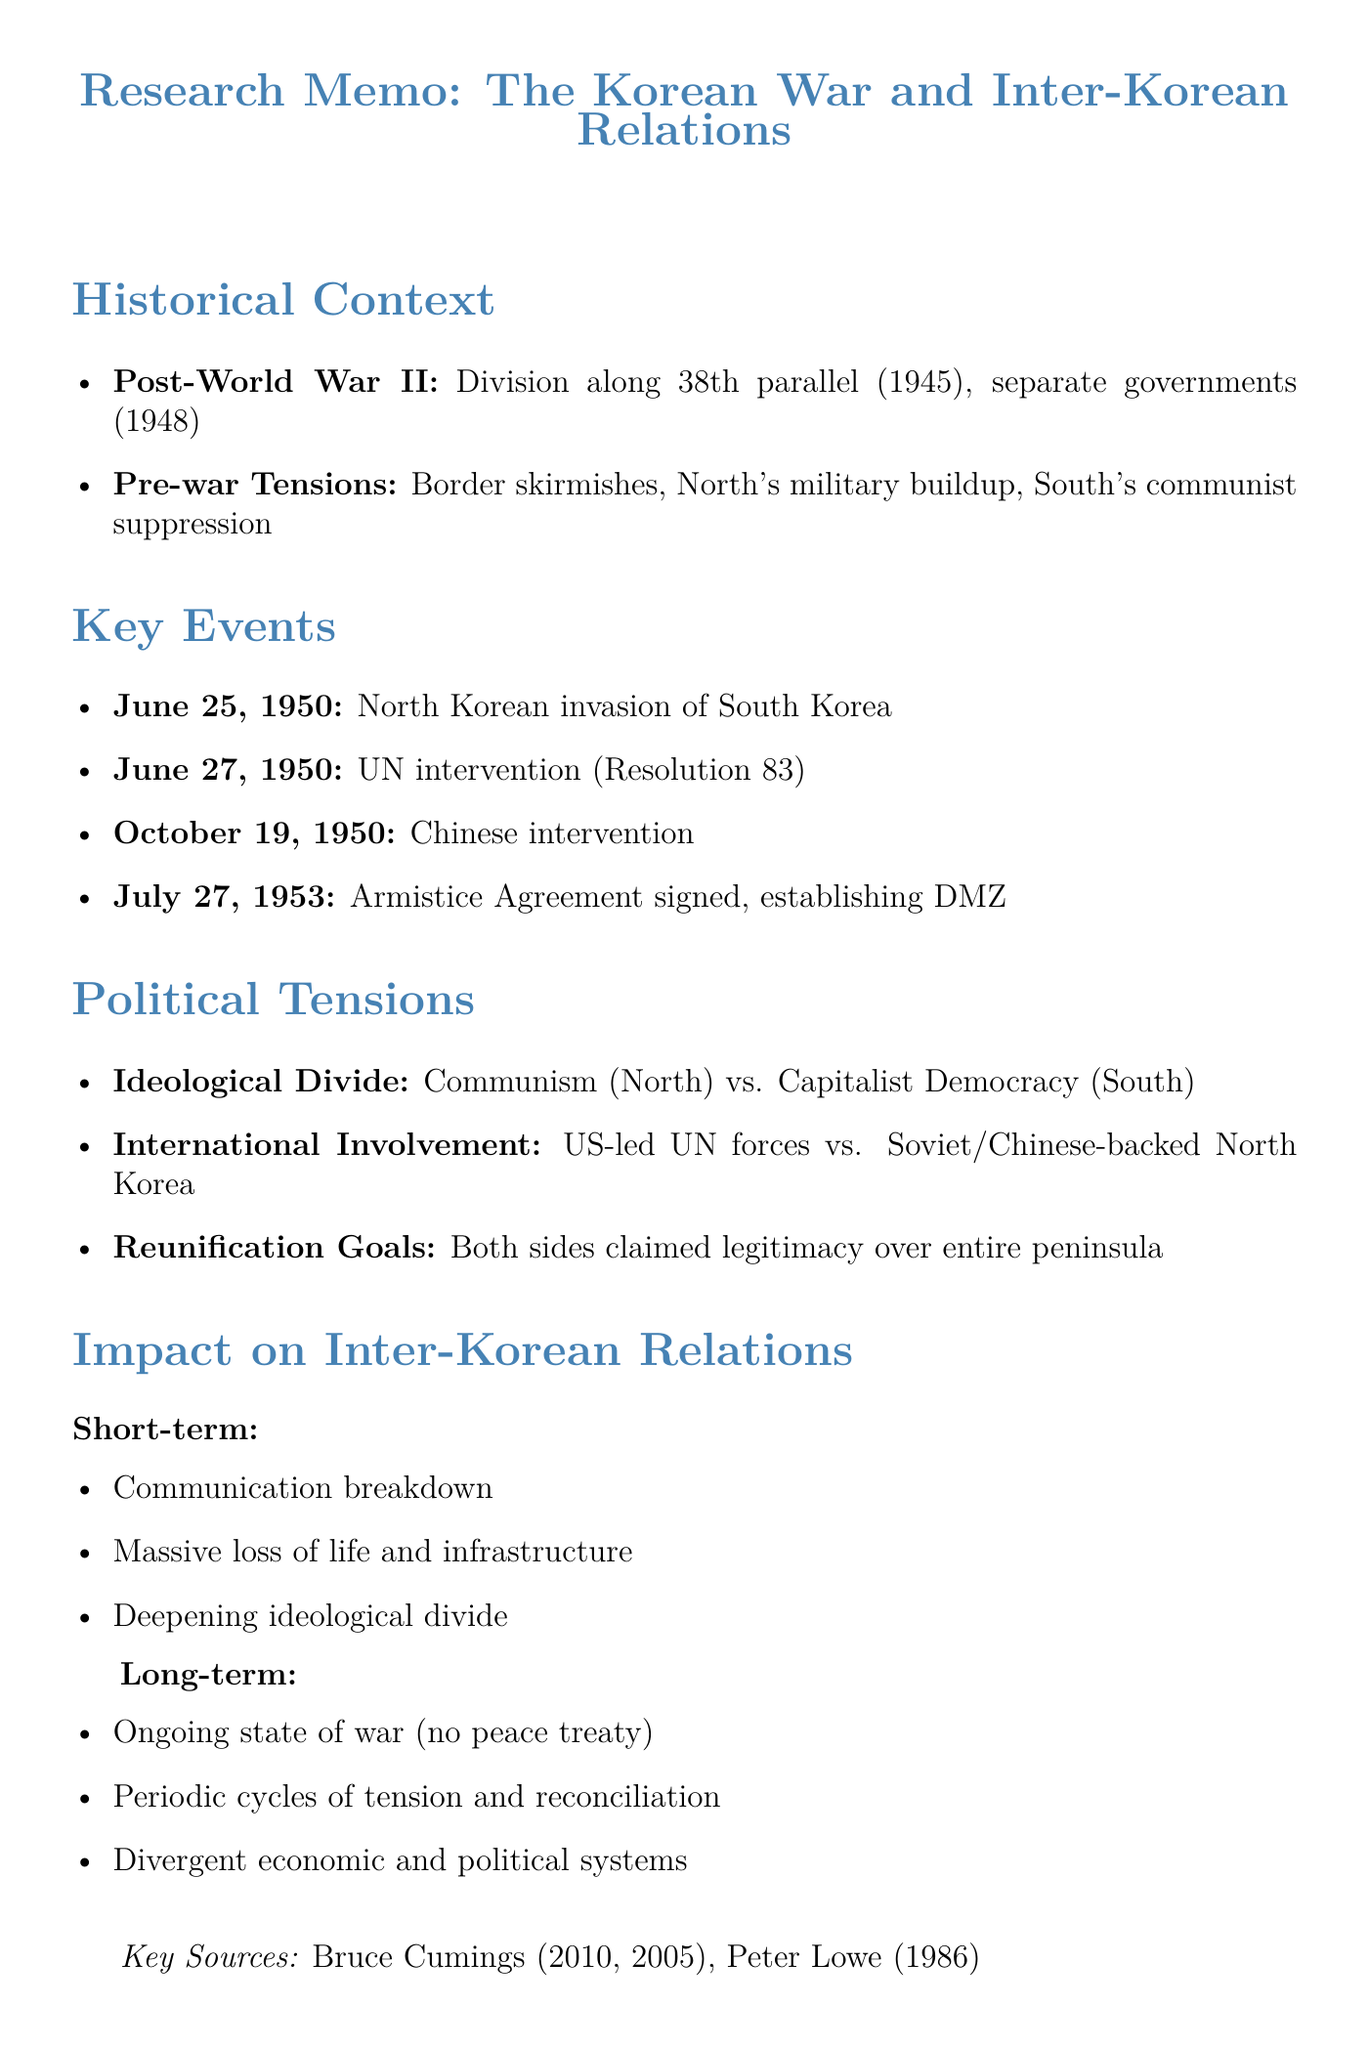what event initiated the Korean War? The document states that North Korean forces crossed the 38th parallel, marking the beginning of the war.
Answer: North Korean invasion of South Korea when was the Armistice Agreement signed? The document lists the date when the Armistice Agreement was signed.
Answer: July 27, 1953 who were the key figures representing the ideological divide? The document identifies key figures for both the North and South in relation to their ideological beliefs.
Answer: Kim Il-sung, Syngman Rhee what was a significant outcome of the Korean War on inter-Korean relations in the short term? The document mentions several immediate impacts, one of which is the complete breakdown of communication.
Answer: Complete breakdown of communication which country intervened in October 1950? The document specifies which country entered the conflict to support North Korea.
Answer: People's Republic of China what resolution authorized UN military assistance to South Korea? The document explicitly states the resolution that authorized military assistance.
Answer: Resolution 83 what aspect of international involvement is highlighted? The document describes the nature of international involvement during the war as a proxy conflict.
Answer: Proxy war what is one long-term impact mentioned related to economic systems? The document references divergent economic systems as a consequence of the war.
Answer: Divergent economic and political systems 